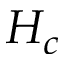<formula> <loc_0><loc_0><loc_500><loc_500>H _ { c }</formula> 